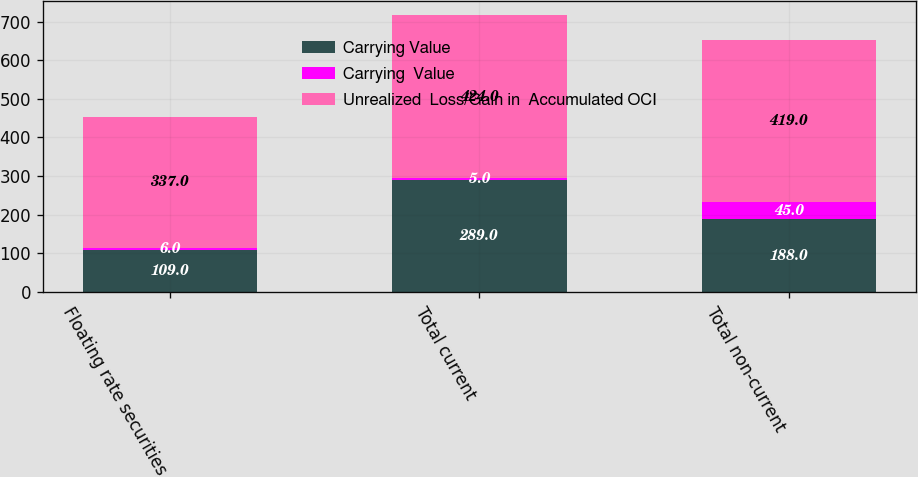Convert chart to OTSL. <chart><loc_0><loc_0><loc_500><loc_500><stacked_bar_chart><ecel><fcel>Floating rate securities<fcel>Total current<fcel>Total non-current<nl><fcel>Carrying Value<fcel>109<fcel>289<fcel>188<nl><fcel>Carrying  Value<fcel>6<fcel>5<fcel>45<nl><fcel>Unrealized  Loss/Gain in  Accumulated OCI<fcel>337<fcel>424<fcel>419<nl></chart> 